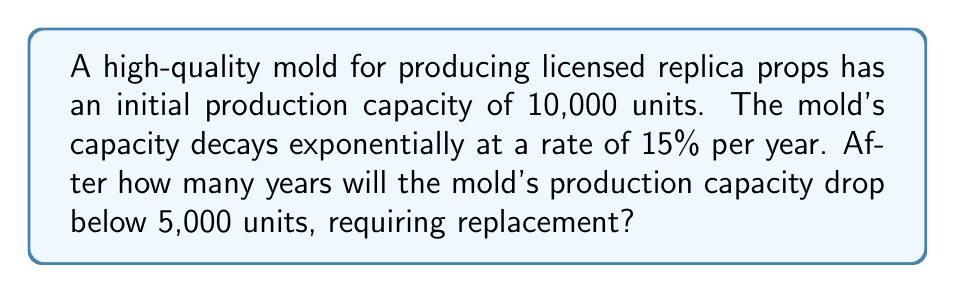Provide a solution to this math problem. Let's approach this step-by-step using an exponential decay function:

1) The exponential decay function is given by:
   $$N(t) = N_0 e^{-rt}$$
   where:
   $N(t)$ is the capacity at time $t$
   $N_0$ is the initial capacity
   $r$ is the decay rate
   $t$ is the time in years

2) We're given:
   $N_0 = 10,000$
   $r = 0.15$ (15% per year)
   We need to find $t$ when $N(t) = 5,000$

3) Substituting into the equation:
   $$5,000 = 10,000 e^{-0.15t}$$

4) Dividing both sides by 10,000:
   $$0.5 = e^{-0.15t}$$

5) Taking the natural logarithm of both sides:
   $$\ln(0.5) = -0.15t$$

6) Solving for $t$:
   $$t = -\frac{\ln(0.5)}{0.15}$$

7) Calculate:
   $$t = -\frac{-0.69314718}{0.15} \approx 4.62$$

8) Since we can't have a fractional year in this context, we round up to the nearest whole year.
Answer: 5 years 